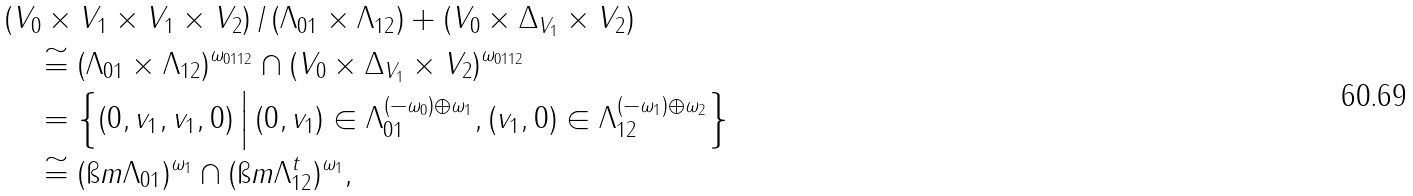Convert formula to latex. <formula><loc_0><loc_0><loc_500><loc_500>& ( V _ { 0 } \times V _ { 1 } \times V _ { 1 } \times V _ { 2 } ) \, / \, ( \Lambda _ { 0 1 } \times \Lambda _ { 1 2 } ) + ( V _ { 0 } \times \Delta _ { V _ { 1 } } \times V _ { 2 } ) \\ & \quad \cong ( \Lambda _ { 0 1 } \times \Lambda _ { 1 2 } ) ^ { \omega _ { 0 1 1 2 } } \cap ( V _ { 0 } \times \Delta _ { V _ { 1 } } \times V _ { 2 } ) ^ { \omega _ { 0 1 1 2 } } \\ & \quad = \Big \{ ( 0 , v _ { 1 } , v _ { 1 } , 0 ) \, \Big | \, ( 0 , v _ { 1 } ) \in \Lambda _ { 0 1 } ^ { ( - \omega _ { 0 } ) \oplus \omega _ { 1 } } , ( v _ { 1 } , 0 ) \in \Lambda _ { 1 2 } ^ { ( - \omega _ { 1 } ) \oplus \omega _ { 2 } } \Big \} \\ & \quad \cong ( \i m \Lambda _ { 0 1 } ) ^ { \omega _ { 1 } } \cap ( \i m \Lambda _ { 1 2 } ^ { t } ) ^ { \omega _ { 1 } } ,</formula> 